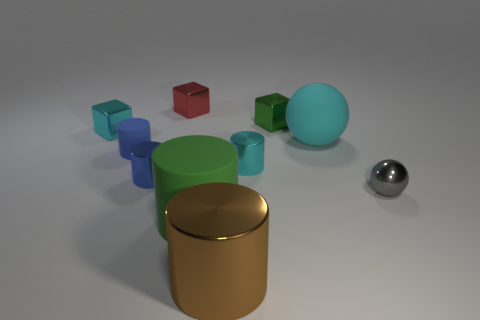How big is the metal object that is on the left side of the brown thing and in front of the large cyan rubber thing?
Provide a succinct answer. Small. What color is the large thing that is made of the same material as the tiny green object?
Provide a short and direct response. Brown. How many big brown things are made of the same material as the big green cylinder?
Offer a very short reply. 0. Are there the same number of blue metal cylinders behind the tiny green metal thing and red cubes that are behind the small cyan cube?
Provide a short and direct response. No. Do the big cyan object and the green object in front of the large cyan matte ball have the same shape?
Ensure brevity in your answer.  No. What is the material of the other tiny cylinder that is the same color as the small matte cylinder?
Ensure brevity in your answer.  Metal. Is there anything else that is the same shape as the blue rubber thing?
Your response must be concise. Yes. Is the red cube made of the same material as the cyan object that is left of the green rubber object?
Provide a succinct answer. Yes. The tiny metal object that is on the right side of the matte object that is behind the tiny blue matte thing that is on the left side of the blue metallic cylinder is what color?
Ensure brevity in your answer.  Gray. Is there any other thing that has the same size as the brown object?
Your answer should be very brief. Yes. 